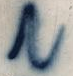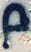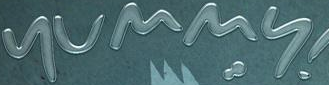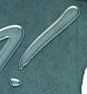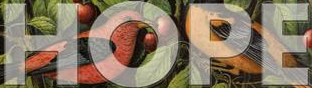Transcribe the words shown in these images in order, separated by a semicolon. N; p; yummy; !; HOPE 